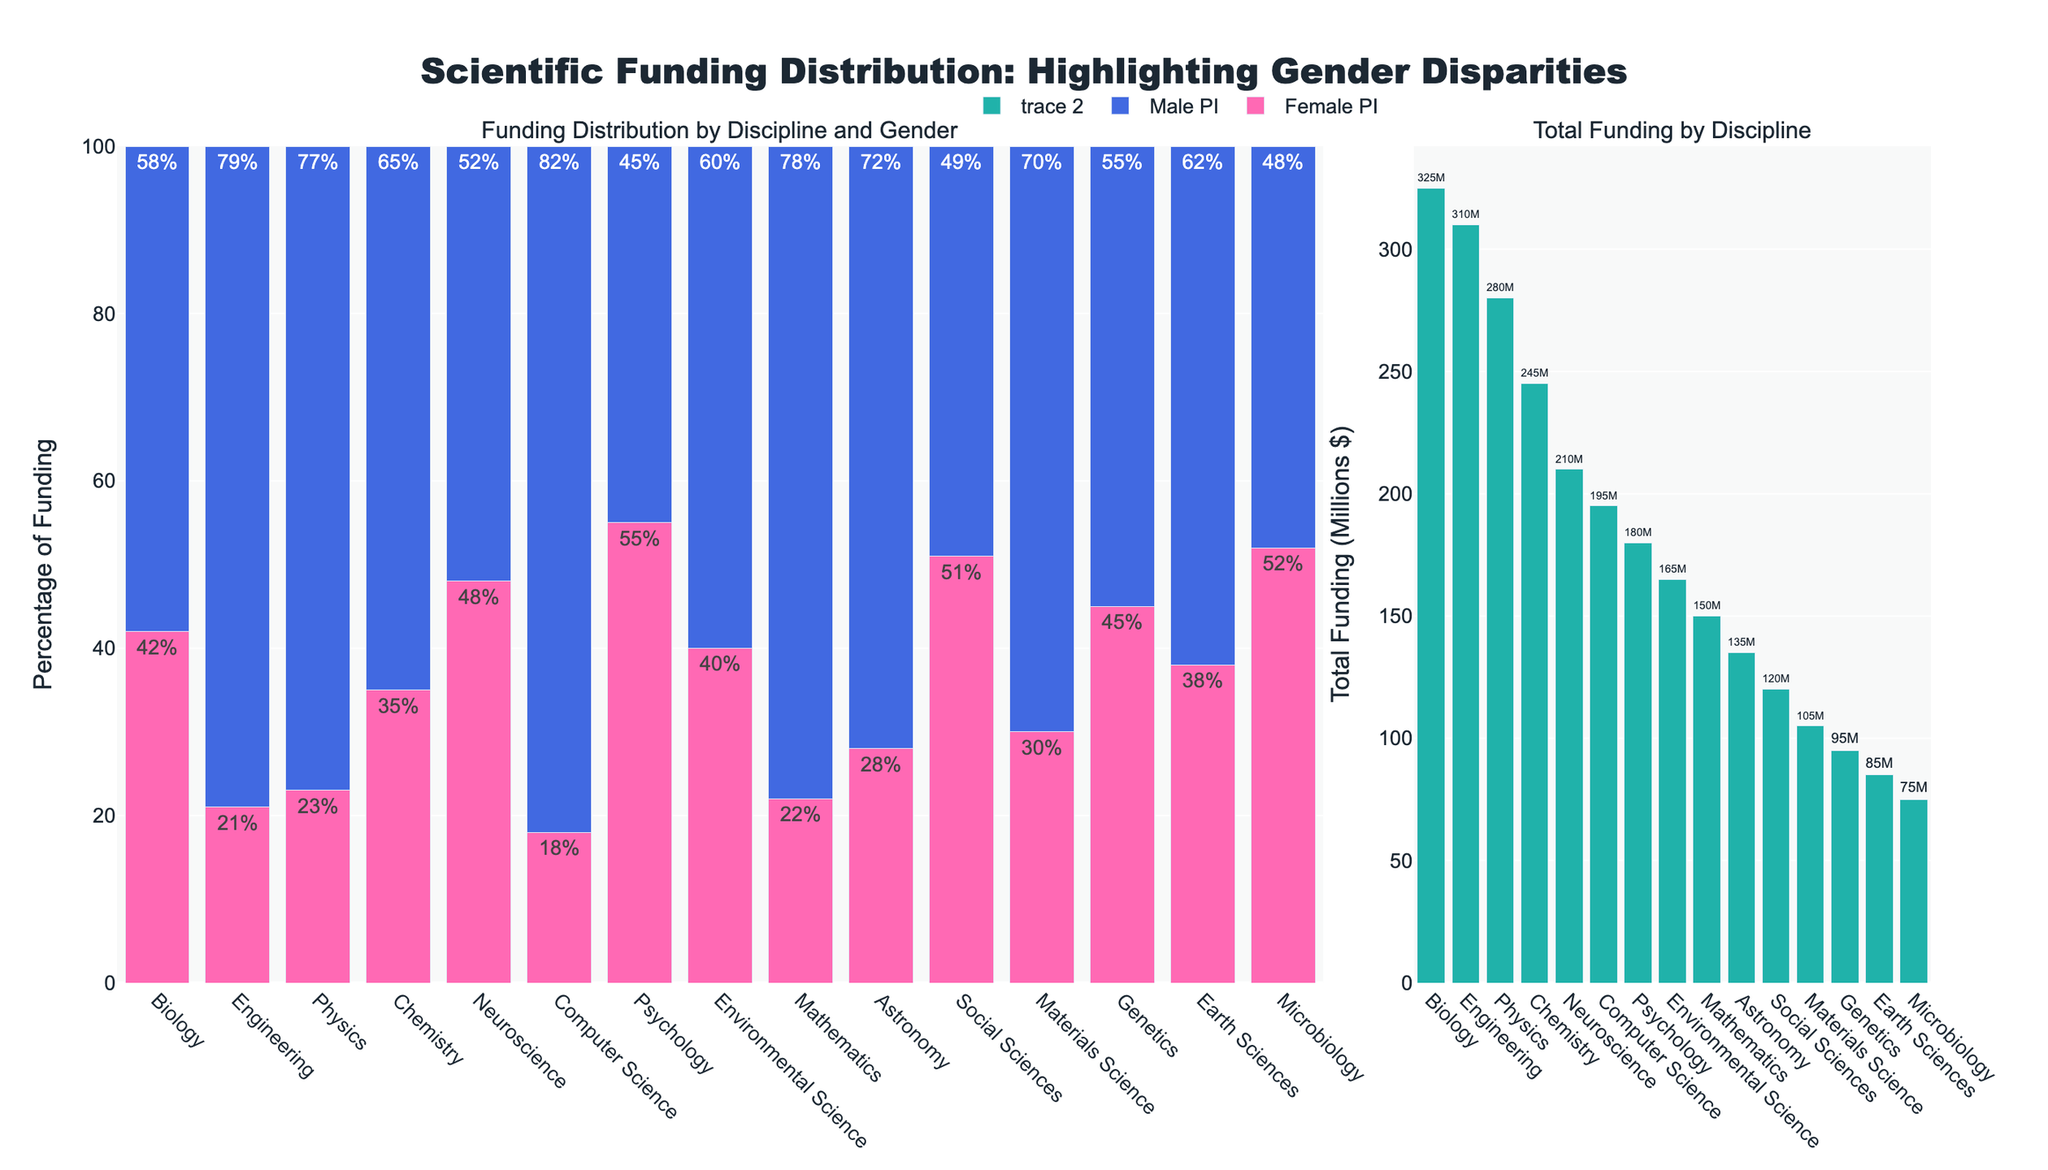What scientific discipline receives the most total funding? To determine the discipline with the most total funding, look for the highest bar in the "Total Funding by Discipline" subplot. Biology, with the highest bar, receives the most funding overall.
Answer: Biology In which discipline do female PIs receive the highest percentage of funding? Look for the bar representing the female PIs that reaches the highest in the "Funding Distribution by Discipline and Gender" subplot. The highest bar for female PIs is in Psychology, indicating it has the highest percentage of female PI funding.
Answer: Psychology What is the combined percentage of funding for female PIs in Biology and Neuroscience? To find the total percentage, sum the percentage values of female PI funding in Biology (42%) and Neuroscience (48%). 42 + 48 = 90.
Answer: 90% Which discipline has the largest gender disparity in funding? To identify the largest gender disparity, find the discipline with the greatest difference between the male and female PI funding percentages by visually comparing the lengths of the bars for each discipline. Physics shows the largest disparity with 77% male and 23% female, a difference of 54%.
Answer: Physics Among Computer Science and Mathematics, which one provides a higher percentage of funding to female PIs? Compare the heights of the bars for female PI funding in the "Funding Distribution by Discipline and Gender" subplot. Computer Science has 18% female funding, and Mathematics has 22% female funding. Thus, Mathematics provides a higher percentage.
Answer: Mathematics How much total funding does Chemistry receive, and what percentage of that is allocated to female PIs? First, find the total funding for Chemistry in the "Total Funding by Discipline" subplot, which is indicated by the bar labeled with "245M". Then, from the "Funding Distribution by Discipline and Gender" subplot, the female PI funding for Chemistry is 35%.
Answer: 245M, 35% Which disciplines have a nearly equal distribution of funding between male and female PIs? Look for disciplines where the bars for male and female PIs are of nearly equal height. Both Psychology (55% female, 45% male) and Social Sciences (51% female, 49% male) have almost equal distributions.
Answer: Psychology and Social Sciences In which disciplines do male PIs receive more than 70% of the funding? Search for disciplines where the bar for male PI funding exceeds 70% in the "Funding Distribution by Discipline and Gender" subplot. The disciplines meeting this criterion are Physics (77%), Computer Science (82%), Mathematics (78%), Astronomy (72%), and Engineering (79%).
Answer: Physics, Computer Science, Mathematics, Astronomy, Engineering What is the average percentage of funding received by female PIs across all disciplines? To find the average, sum the percentages of female PI funding for all disciplines and divide by the number of disciplines. Summing (42 + 23 + 35 + 48 + 18 + 55 + 40 + 22 + 28 + 21 + 51 + 30 + 45 + 38 + 52) = 548. With 15 disciplines, 548 / 15 ≈ 36.53%.
Answer: 36.53% How much more funding does Engineering receive compared to Genetics, and what does this suggest about funding priorities? First, find the total funding for Engineering (310M) and Genetics (95M) in the "Total Funding by Discipline" subplot. Subtract the Genetic funding from Engineering funding: 310 - 95 = 215. This suggests that engineering may be prioritized significantly more in funding distribution.
Answer: 215M, Engineering is significantly prioritized 